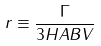Convert formula to latex. <formula><loc_0><loc_0><loc_500><loc_500>r \equiv \frac { \Gamma } { 3 H A B V }</formula> 